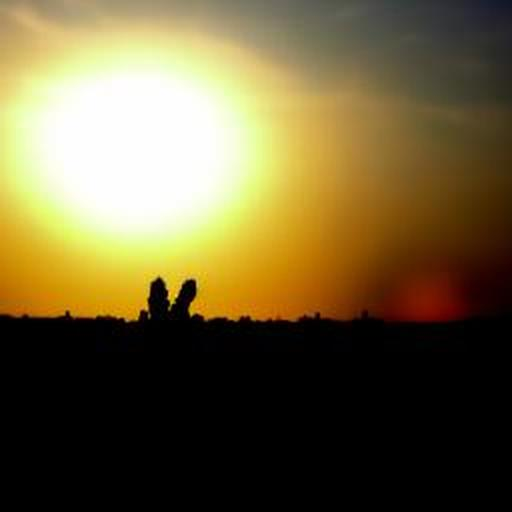Could you suggest the best settings to capture such an image? To capture such a sunset silhouette image, you'd want to use a low ISO to reduce noise, a narrow aperture to ensure the silhouetted figures are sharply defined, and a fast shutter speed to preserve the colors without overexposure. 